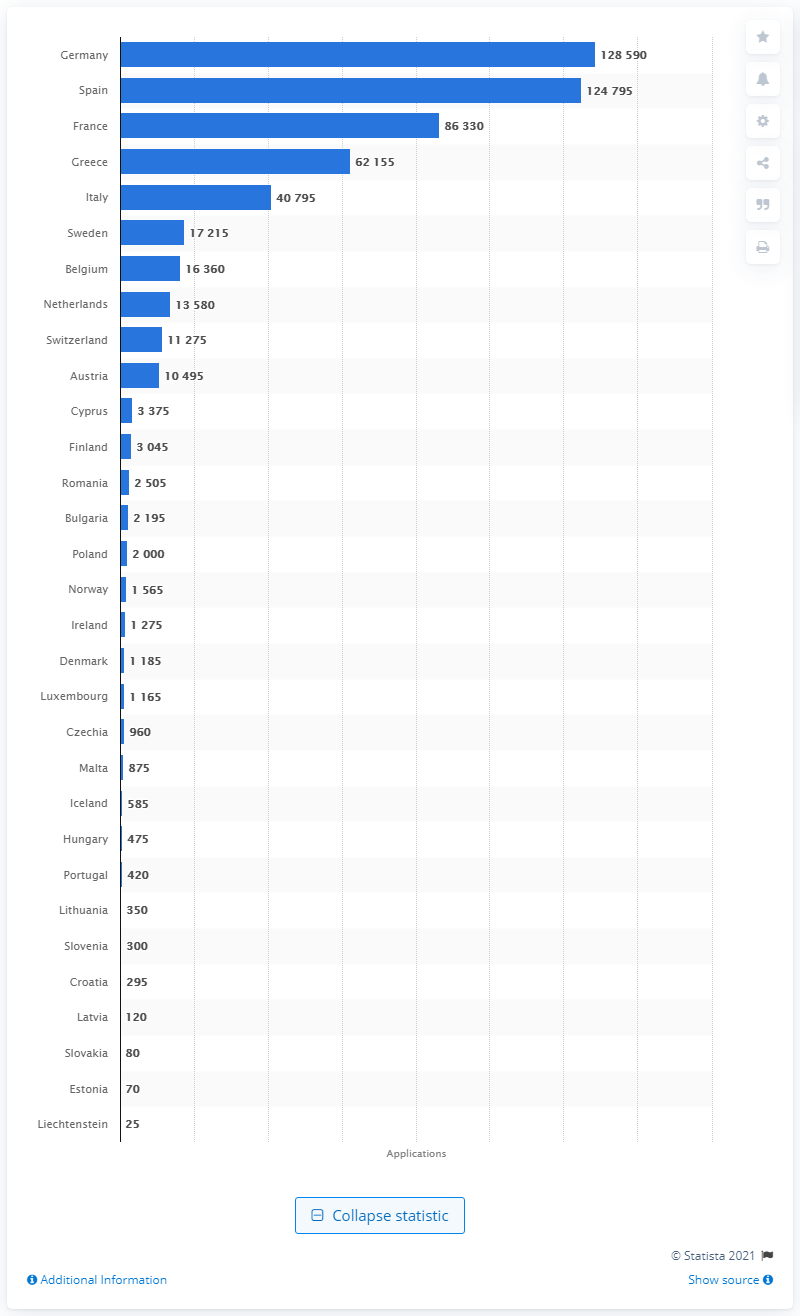Give some essential details in this illustration. In 2020, France had a total of 124,795 asylum seekers. In 2020, Germany had a total of 128,590 asylum seekers. 